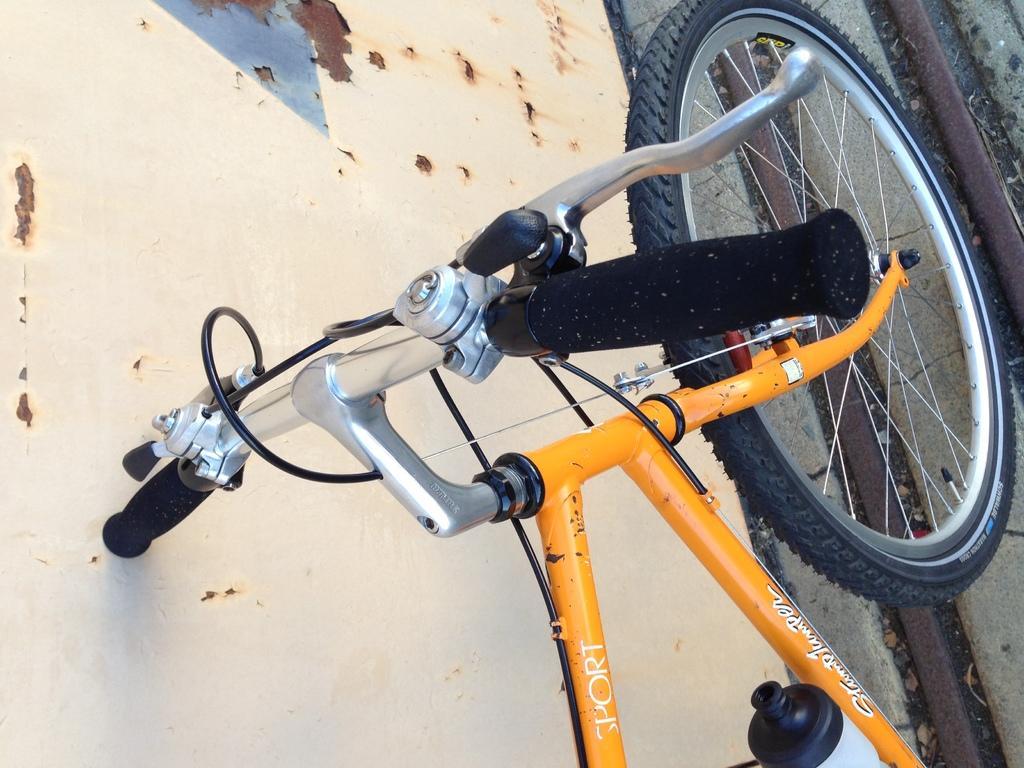Describe this image in one or two sentences. It is a zoomed in picture of a bicycle parked on the path. We can also see the wall. 